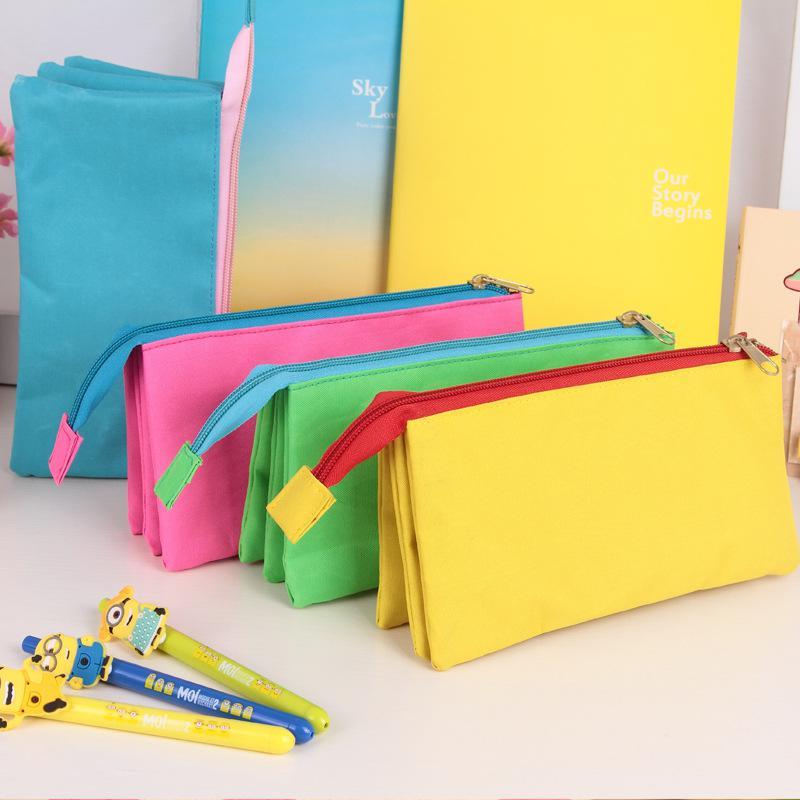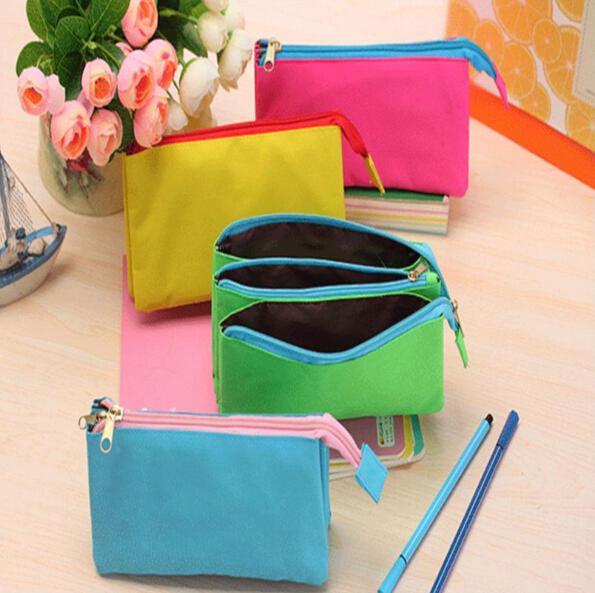The first image is the image on the left, the second image is the image on the right. Considering the images on both sides, is "One image shows exactly four closed pencil cases of different solid colors, designed with zippers that extend around rounded corners." valid? Answer yes or no. No. The first image is the image on the left, the second image is the image on the right. Analyze the images presented: Is the assertion "Contents are poking out of one of the bags in the image on the left." valid? Answer yes or no. No. 